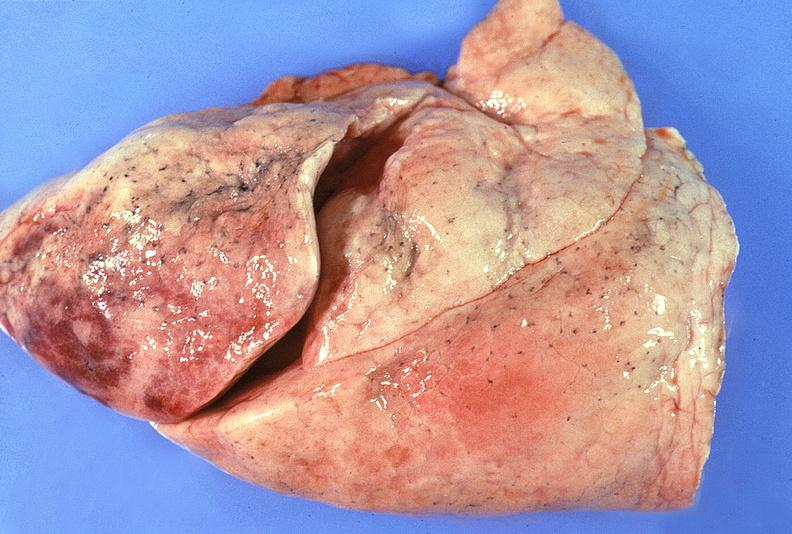does this image show normal lung?
Answer the question using a single word or phrase. Yes 